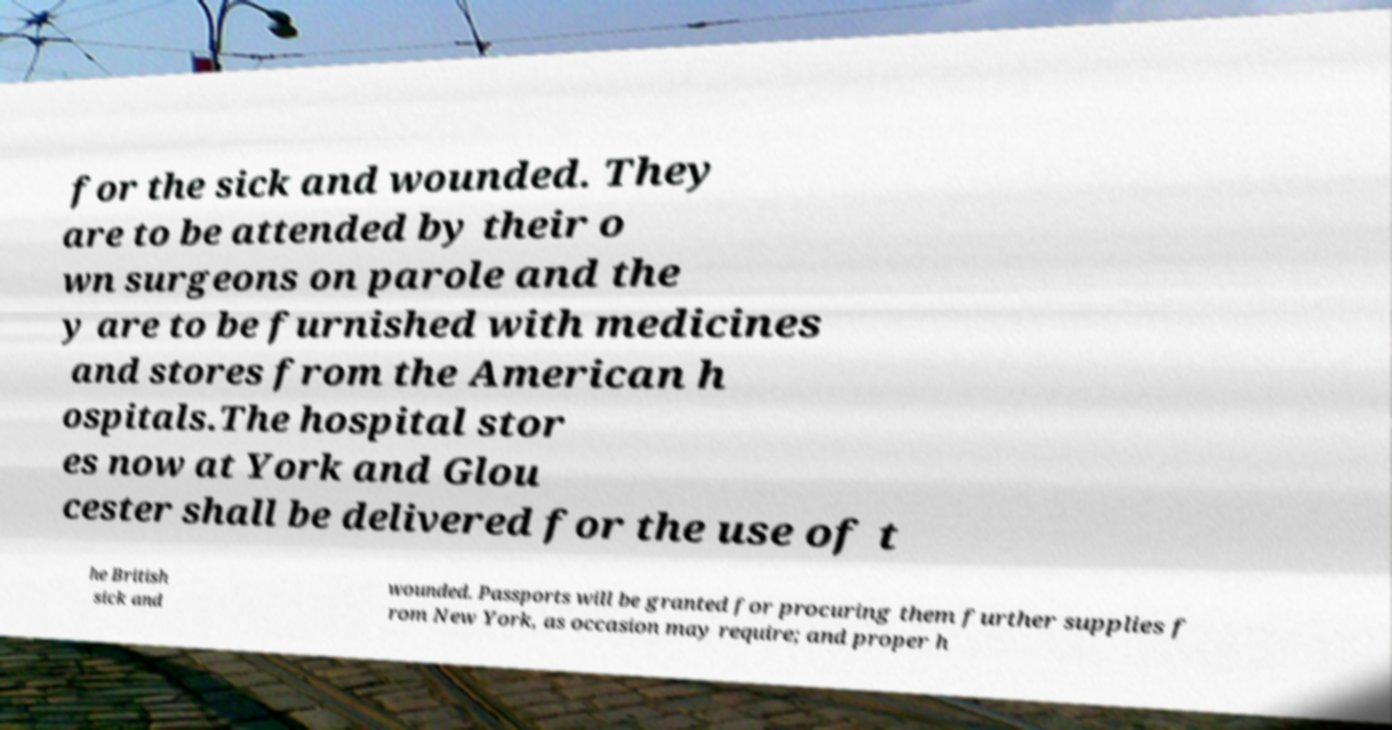Can you accurately transcribe the text from the provided image for me? for the sick and wounded. They are to be attended by their o wn surgeons on parole and the y are to be furnished with medicines and stores from the American h ospitals.The hospital stor es now at York and Glou cester shall be delivered for the use of t he British sick and wounded. Passports will be granted for procuring them further supplies f rom New York, as occasion may require; and proper h 